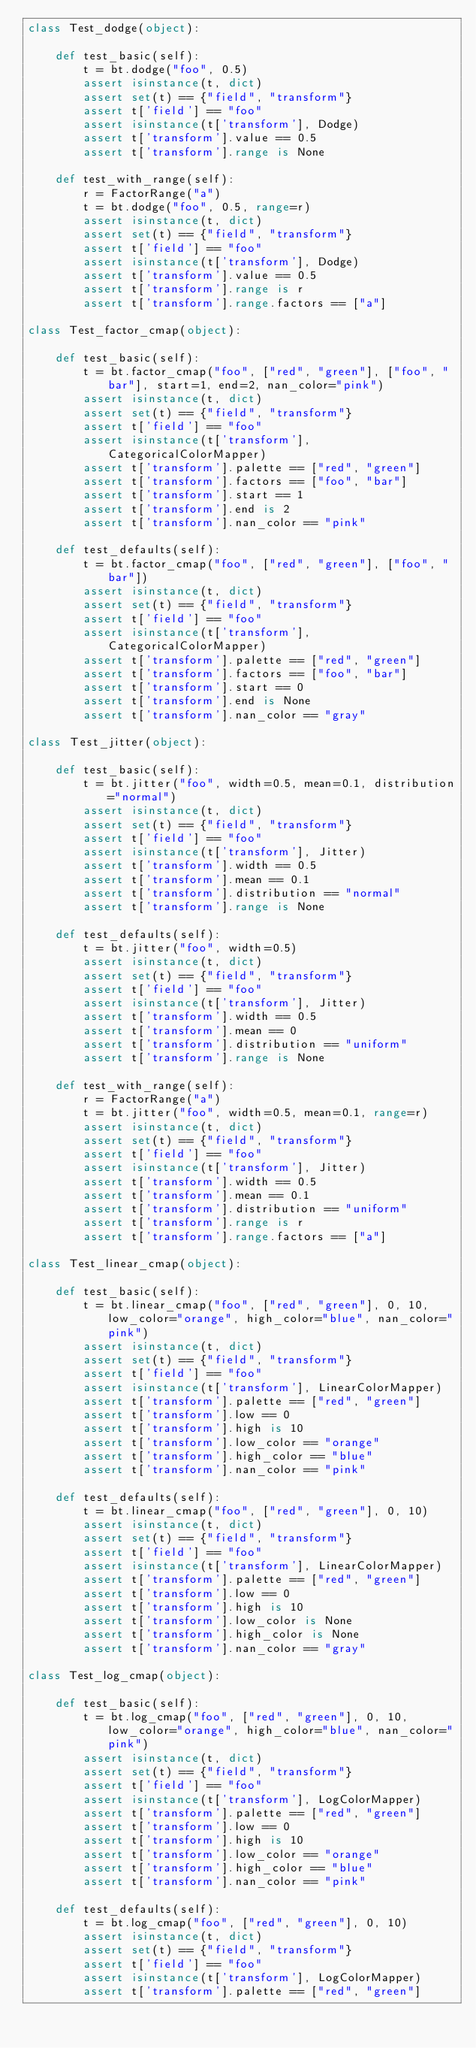Convert code to text. <code><loc_0><loc_0><loc_500><loc_500><_Python_>class Test_dodge(object):

    def test_basic(self):
        t = bt.dodge("foo", 0.5)
        assert isinstance(t, dict)
        assert set(t) == {"field", "transform"}
        assert t['field'] == "foo"
        assert isinstance(t['transform'], Dodge)
        assert t['transform'].value == 0.5
        assert t['transform'].range is None

    def test_with_range(self):
        r = FactorRange("a")
        t = bt.dodge("foo", 0.5, range=r)
        assert isinstance(t, dict)
        assert set(t) == {"field", "transform"}
        assert t['field'] == "foo"
        assert isinstance(t['transform'], Dodge)
        assert t['transform'].value == 0.5
        assert t['transform'].range is r
        assert t['transform'].range.factors == ["a"]

class Test_factor_cmap(object):

    def test_basic(self):
        t = bt.factor_cmap("foo", ["red", "green"], ["foo", "bar"], start=1, end=2, nan_color="pink")
        assert isinstance(t, dict)
        assert set(t) == {"field", "transform"}
        assert t['field'] == "foo"
        assert isinstance(t['transform'], CategoricalColorMapper)
        assert t['transform'].palette == ["red", "green"]
        assert t['transform'].factors == ["foo", "bar"]
        assert t['transform'].start == 1
        assert t['transform'].end is 2
        assert t['transform'].nan_color == "pink"

    def test_defaults(self):
        t = bt.factor_cmap("foo", ["red", "green"], ["foo", "bar"])
        assert isinstance(t, dict)
        assert set(t) == {"field", "transform"}
        assert t['field'] == "foo"
        assert isinstance(t['transform'], CategoricalColorMapper)
        assert t['transform'].palette == ["red", "green"]
        assert t['transform'].factors == ["foo", "bar"]
        assert t['transform'].start == 0
        assert t['transform'].end is None
        assert t['transform'].nan_color == "gray"

class Test_jitter(object):

    def test_basic(self):
        t = bt.jitter("foo", width=0.5, mean=0.1, distribution="normal")
        assert isinstance(t, dict)
        assert set(t) == {"field", "transform"}
        assert t['field'] == "foo"
        assert isinstance(t['transform'], Jitter)
        assert t['transform'].width == 0.5
        assert t['transform'].mean == 0.1
        assert t['transform'].distribution == "normal"
        assert t['transform'].range is None

    def test_defaults(self):
        t = bt.jitter("foo", width=0.5)
        assert isinstance(t, dict)
        assert set(t) == {"field", "transform"}
        assert t['field'] == "foo"
        assert isinstance(t['transform'], Jitter)
        assert t['transform'].width == 0.5
        assert t['transform'].mean == 0
        assert t['transform'].distribution == "uniform"
        assert t['transform'].range is None

    def test_with_range(self):
        r = FactorRange("a")
        t = bt.jitter("foo", width=0.5, mean=0.1, range=r)
        assert isinstance(t, dict)
        assert set(t) == {"field", "transform"}
        assert t['field'] == "foo"
        assert isinstance(t['transform'], Jitter)
        assert t['transform'].width == 0.5
        assert t['transform'].mean == 0.1
        assert t['transform'].distribution == "uniform"
        assert t['transform'].range is r
        assert t['transform'].range.factors == ["a"]

class Test_linear_cmap(object):

    def test_basic(self):
        t = bt.linear_cmap("foo", ["red", "green"], 0, 10, low_color="orange", high_color="blue", nan_color="pink")
        assert isinstance(t, dict)
        assert set(t) == {"field", "transform"}
        assert t['field'] == "foo"
        assert isinstance(t['transform'], LinearColorMapper)
        assert t['transform'].palette == ["red", "green"]
        assert t['transform'].low == 0
        assert t['transform'].high is 10
        assert t['transform'].low_color == "orange"
        assert t['transform'].high_color == "blue"
        assert t['transform'].nan_color == "pink"

    def test_defaults(self):
        t = bt.linear_cmap("foo", ["red", "green"], 0, 10)
        assert isinstance(t, dict)
        assert set(t) == {"field", "transform"}
        assert t['field'] == "foo"
        assert isinstance(t['transform'], LinearColorMapper)
        assert t['transform'].palette == ["red", "green"]
        assert t['transform'].low == 0
        assert t['transform'].high is 10
        assert t['transform'].low_color is None
        assert t['transform'].high_color is None
        assert t['transform'].nan_color == "gray"

class Test_log_cmap(object):

    def test_basic(self):
        t = bt.log_cmap("foo", ["red", "green"], 0, 10, low_color="orange", high_color="blue", nan_color="pink")
        assert isinstance(t, dict)
        assert set(t) == {"field", "transform"}
        assert t['field'] == "foo"
        assert isinstance(t['transform'], LogColorMapper)
        assert t['transform'].palette == ["red", "green"]
        assert t['transform'].low == 0
        assert t['transform'].high is 10
        assert t['transform'].low_color == "orange"
        assert t['transform'].high_color == "blue"
        assert t['transform'].nan_color == "pink"

    def test_defaults(self):
        t = bt.log_cmap("foo", ["red", "green"], 0, 10)
        assert isinstance(t, dict)
        assert set(t) == {"field", "transform"}
        assert t['field'] == "foo"
        assert isinstance(t['transform'], LogColorMapper)
        assert t['transform'].palette == ["red", "green"]</code> 